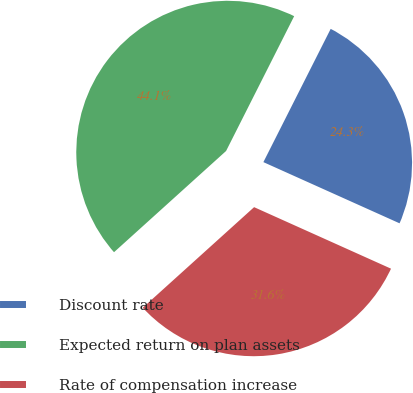<chart> <loc_0><loc_0><loc_500><loc_500><pie_chart><fcel>Discount rate<fcel>Expected return on plan assets<fcel>Rate of compensation increase<nl><fcel>24.28%<fcel>44.14%<fcel>31.59%<nl></chart> 